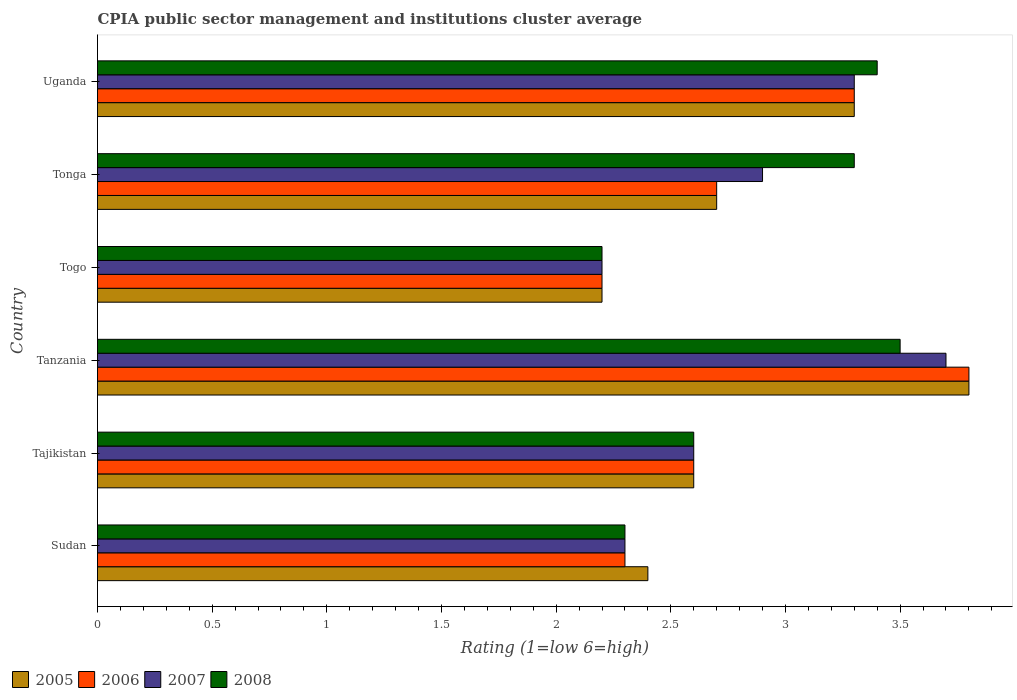How many different coloured bars are there?
Keep it short and to the point. 4. How many bars are there on the 1st tick from the top?
Provide a short and direct response. 4. How many bars are there on the 4th tick from the bottom?
Offer a terse response. 4. What is the label of the 1st group of bars from the top?
Keep it short and to the point. Uganda. What is the CPIA rating in 2008 in Tanzania?
Your response must be concise. 3.5. Across all countries, what is the maximum CPIA rating in 2006?
Offer a terse response. 3.8. Across all countries, what is the minimum CPIA rating in 2007?
Ensure brevity in your answer.  2.2. In which country was the CPIA rating in 2006 maximum?
Your response must be concise. Tanzania. In which country was the CPIA rating in 2005 minimum?
Your answer should be compact. Togo. What is the total CPIA rating in 2008 in the graph?
Ensure brevity in your answer.  17.3. What is the difference between the CPIA rating in 2008 in Tajikistan and that in Tanzania?
Ensure brevity in your answer.  -0.9. What is the difference between the CPIA rating in 2005 in Togo and the CPIA rating in 2008 in Uganda?
Offer a very short reply. -1.2. What is the average CPIA rating in 2008 per country?
Your answer should be very brief. 2.88. What is the difference between the CPIA rating in 2005 and CPIA rating in 2007 in Tanzania?
Provide a short and direct response. 0.1. In how many countries, is the CPIA rating in 2005 greater than 3.4 ?
Give a very brief answer. 1. What is the ratio of the CPIA rating in 2006 in Sudan to that in Togo?
Keep it short and to the point. 1.05. Is the difference between the CPIA rating in 2005 in Tonga and Uganda greater than the difference between the CPIA rating in 2007 in Tonga and Uganda?
Provide a succinct answer. No. What is the difference between the highest and the lowest CPIA rating in 2008?
Keep it short and to the point. 1.3. Is it the case that in every country, the sum of the CPIA rating in 2005 and CPIA rating in 2007 is greater than the sum of CPIA rating in 2006 and CPIA rating in 2008?
Your response must be concise. No. Are all the bars in the graph horizontal?
Ensure brevity in your answer.  Yes. How many countries are there in the graph?
Offer a terse response. 6. Are the values on the major ticks of X-axis written in scientific E-notation?
Offer a very short reply. No. Does the graph contain any zero values?
Your response must be concise. No. Does the graph contain grids?
Keep it short and to the point. No. Where does the legend appear in the graph?
Provide a short and direct response. Bottom left. How many legend labels are there?
Provide a succinct answer. 4. How are the legend labels stacked?
Provide a short and direct response. Horizontal. What is the title of the graph?
Ensure brevity in your answer.  CPIA public sector management and institutions cluster average. What is the Rating (1=low 6=high) of 2005 in Sudan?
Your answer should be very brief. 2.4. What is the Rating (1=low 6=high) in 2006 in Sudan?
Make the answer very short. 2.3. What is the Rating (1=low 6=high) of 2008 in Tajikistan?
Offer a very short reply. 2.6. What is the Rating (1=low 6=high) of 2007 in Tanzania?
Offer a terse response. 3.7. What is the Rating (1=low 6=high) of 2005 in Togo?
Keep it short and to the point. 2.2. What is the Rating (1=low 6=high) of 2008 in Togo?
Offer a terse response. 2.2. What is the Rating (1=low 6=high) of 2005 in Tonga?
Ensure brevity in your answer.  2.7. What is the Rating (1=low 6=high) in 2007 in Tonga?
Give a very brief answer. 2.9. What is the Rating (1=low 6=high) in 2008 in Tonga?
Keep it short and to the point. 3.3. What is the Rating (1=low 6=high) of 2005 in Uganda?
Your answer should be very brief. 3.3. What is the Rating (1=low 6=high) of 2008 in Uganda?
Offer a terse response. 3.4. Across all countries, what is the maximum Rating (1=low 6=high) in 2006?
Your answer should be very brief. 3.8. Across all countries, what is the maximum Rating (1=low 6=high) of 2007?
Offer a terse response. 3.7. Across all countries, what is the maximum Rating (1=low 6=high) of 2008?
Your answer should be compact. 3.5. What is the total Rating (1=low 6=high) in 2007 in the graph?
Provide a succinct answer. 17. What is the difference between the Rating (1=low 6=high) of 2005 in Sudan and that in Tajikistan?
Offer a terse response. -0.2. What is the difference between the Rating (1=low 6=high) of 2006 in Sudan and that in Tajikistan?
Ensure brevity in your answer.  -0.3. What is the difference between the Rating (1=low 6=high) of 2008 in Sudan and that in Tajikistan?
Offer a terse response. -0.3. What is the difference between the Rating (1=low 6=high) in 2005 in Sudan and that in Tanzania?
Give a very brief answer. -1.4. What is the difference between the Rating (1=low 6=high) in 2006 in Sudan and that in Tanzania?
Your answer should be very brief. -1.5. What is the difference between the Rating (1=low 6=high) in 2006 in Sudan and that in Tonga?
Offer a very short reply. -0.4. What is the difference between the Rating (1=low 6=high) in 2007 in Sudan and that in Tonga?
Keep it short and to the point. -0.6. What is the difference between the Rating (1=low 6=high) of 2008 in Sudan and that in Tonga?
Keep it short and to the point. -1. What is the difference between the Rating (1=low 6=high) in 2006 in Sudan and that in Uganda?
Your answer should be very brief. -1. What is the difference between the Rating (1=low 6=high) in 2008 in Sudan and that in Uganda?
Give a very brief answer. -1.1. What is the difference between the Rating (1=low 6=high) in 2005 in Tajikistan and that in Tanzania?
Keep it short and to the point. -1.2. What is the difference between the Rating (1=low 6=high) of 2006 in Tajikistan and that in Tanzania?
Your answer should be compact. -1.2. What is the difference between the Rating (1=low 6=high) of 2007 in Tajikistan and that in Tanzania?
Your answer should be very brief. -1.1. What is the difference between the Rating (1=low 6=high) in 2006 in Tajikistan and that in Tonga?
Keep it short and to the point. -0.1. What is the difference between the Rating (1=low 6=high) of 2008 in Tajikistan and that in Tonga?
Ensure brevity in your answer.  -0.7. What is the difference between the Rating (1=low 6=high) in 2005 in Tajikistan and that in Uganda?
Your response must be concise. -0.7. What is the difference between the Rating (1=low 6=high) of 2007 in Tajikistan and that in Uganda?
Offer a terse response. -0.7. What is the difference between the Rating (1=low 6=high) of 2005 in Tanzania and that in Togo?
Ensure brevity in your answer.  1.6. What is the difference between the Rating (1=low 6=high) in 2008 in Tanzania and that in Togo?
Make the answer very short. 1.3. What is the difference between the Rating (1=low 6=high) of 2006 in Tanzania and that in Tonga?
Your answer should be compact. 1.1. What is the difference between the Rating (1=low 6=high) of 2007 in Tanzania and that in Tonga?
Ensure brevity in your answer.  0.8. What is the difference between the Rating (1=low 6=high) of 2008 in Tanzania and that in Tonga?
Provide a succinct answer. 0.2. What is the difference between the Rating (1=low 6=high) of 2005 in Tanzania and that in Uganda?
Provide a succinct answer. 0.5. What is the difference between the Rating (1=low 6=high) of 2005 in Togo and that in Tonga?
Keep it short and to the point. -0.5. What is the difference between the Rating (1=low 6=high) of 2006 in Togo and that in Tonga?
Your answer should be very brief. -0.5. What is the difference between the Rating (1=low 6=high) in 2008 in Togo and that in Tonga?
Offer a very short reply. -1.1. What is the difference between the Rating (1=low 6=high) of 2007 in Tonga and that in Uganda?
Give a very brief answer. -0.4. What is the difference between the Rating (1=low 6=high) in 2006 in Sudan and the Rating (1=low 6=high) in 2008 in Tajikistan?
Provide a short and direct response. -0.3. What is the difference between the Rating (1=low 6=high) in 2005 in Sudan and the Rating (1=low 6=high) in 2007 in Tanzania?
Offer a terse response. -1.3. What is the difference between the Rating (1=low 6=high) in 2005 in Sudan and the Rating (1=low 6=high) in 2008 in Tanzania?
Provide a short and direct response. -1.1. What is the difference between the Rating (1=low 6=high) of 2006 in Sudan and the Rating (1=low 6=high) of 2007 in Tanzania?
Ensure brevity in your answer.  -1.4. What is the difference between the Rating (1=low 6=high) of 2006 in Sudan and the Rating (1=low 6=high) of 2008 in Tanzania?
Keep it short and to the point. -1.2. What is the difference between the Rating (1=low 6=high) in 2007 in Sudan and the Rating (1=low 6=high) in 2008 in Tanzania?
Offer a terse response. -1.2. What is the difference between the Rating (1=low 6=high) of 2005 in Sudan and the Rating (1=low 6=high) of 2006 in Togo?
Give a very brief answer. 0.2. What is the difference between the Rating (1=low 6=high) in 2005 in Sudan and the Rating (1=low 6=high) in 2007 in Togo?
Your answer should be very brief. 0.2. What is the difference between the Rating (1=low 6=high) in 2007 in Sudan and the Rating (1=low 6=high) in 2008 in Togo?
Provide a succinct answer. 0.1. What is the difference between the Rating (1=low 6=high) in 2005 in Sudan and the Rating (1=low 6=high) in 2008 in Tonga?
Provide a succinct answer. -0.9. What is the difference between the Rating (1=low 6=high) of 2006 in Sudan and the Rating (1=low 6=high) of 2008 in Tonga?
Your response must be concise. -1. What is the difference between the Rating (1=low 6=high) of 2007 in Sudan and the Rating (1=low 6=high) of 2008 in Tonga?
Ensure brevity in your answer.  -1. What is the difference between the Rating (1=low 6=high) in 2005 in Sudan and the Rating (1=low 6=high) in 2006 in Uganda?
Ensure brevity in your answer.  -0.9. What is the difference between the Rating (1=low 6=high) in 2005 in Sudan and the Rating (1=low 6=high) in 2008 in Uganda?
Ensure brevity in your answer.  -1. What is the difference between the Rating (1=low 6=high) of 2006 in Sudan and the Rating (1=low 6=high) of 2007 in Uganda?
Offer a very short reply. -1. What is the difference between the Rating (1=low 6=high) of 2006 in Sudan and the Rating (1=low 6=high) of 2008 in Uganda?
Offer a very short reply. -1.1. What is the difference between the Rating (1=low 6=high) in 2007 in Sudan and the Rating (1=low 6=high) in 2008 in Uganda?
Provide a short and direct response. -1.1. What is the difference between the Rating (1=low 6=high) of 2005 in Tajikistan and the Rating (1=low 6=high) of 2006 in Tanzania?
Your response must be concise. -1.2. What is the difference between the Rating (1=low 6=high) of 2005 in Tajikistan and the Rating (1=low 6=high) of 2008 in Tanzania?
Keep it short and to the point. -0.9. What is the difference between the Rating (1=low 6=high) of 2007 in Tajikistan and the Rating (1=low 6=high) of 2008 in Tanzania?
Make the answer very short. -0.9. What is the difference between the Rating (1=low 6=high) in 2005 in Tajikistan and the Rating (1=low 6=high) in 2006 in Togo?
Keep it short and to the point. 0.4. What is the difference between the Rating (1=low 6=high) of 2006 in Tajikistan and the Rating (1=low 6=high) of 2007 in Togo?
Your response must be concise. 0.4. What is the difference between the Rating (1=low 6=high) in 2005 in Tajikistan and the Rating (1=low 6=high) in 2007 in Tonga?
Your answer should be very brief. -0.3. What is the difference between the Rating (1=low 6=high) in 2005 in Tajikistan and the Rating (1=low 6=high) in 2008 in Tonga?
Ensure brevity in your answer.  -0.7. What is the difference between the Rating (1=low 6=high) of 2006 in Tajikistan and the Rating (1=low 6=high) of 2007 in Tonga?
Offer a terse response. -0.3. What is the difference between the Rating (1=low 6=high) in 2007 in Tajikistan and the Rating (1=low 6=high) in 2008 in Tonga?
Provide a succinct answer. -0.7. What is the difference between the Rating (1=low 6=high) in 2005 in Tajikistan and the Rating (1=low 6=high) in 2006 in Uganda?
Your response must be concise. -0.7. What is the difference between the Rating (1=low 6=high) of 2005 in Tajikistan and the Rating (1=low 6=high) of 2007 in Uganda?
Your response must be concise. -0.7. What is the difference between the Rating (1=low 6=high) of 2005 in Tajikistan and the Rating (1=low 6=high) of 2008 in Uganda?
Provide a short and direct response. -0.8. What is the difference between the Rating (1=low 6=high) of 2006 in Tajikistan and the Rating (1=low 6=high) of 2007 in Uganda?
Ensure brevity in your answer.  -0.7. What is the difference between the Rating (1=low 6=high) of 2006 in Tajikistan and the Rating (1=low 6=high) of 2008 in Uganda?
Make the answer very short. -0.8. What is the difference between the Rating (1=low 6=high) in 2005 in Tanzania and the Rating (1=low 6=high) in 2006 in Togo?
Your answer should be compact. 1.6. What is the difference between the Rating (1=low 6=high) of 2005 in Tanzania and the Rating (1=low 6=high) of 2007 in Togo?
Keep it short and to the point. 1.6. What is the difference between the Rating (1=low 6=high) in 2006 in Tanzania and the Rating (1=low 6=high) in 2007 in Togo?
Give a very brief answer. 1.6. What is the difference between the Rating (1=low 6=high) in 2005 in Tanzania and the Rating (1=low 6=high) in 2006 in Tonga?
Your answer should be compact. 1.1. What is the difference between the Rating (1=low 6=high) in 2005 in Tanzania and the Rating (1=low 6=high) in 2006 in Uganda?
Your answer should be very brief. 0.5. What is the difference between the Rating (1=low 6=high) in 2005 in Tanzania and the Rating (1=low 6=high) in 2007 in Uganda?
Your answer should be very brief. 0.5. What is the difference between the Rating (1=low 6=high) of 2006 in Tanzania and the Rating (1=low 6=high) of 2008 in Uganda?
Give a very brief answer. 0.4. What is the difference between the Rating (1=low 6=high) in 2005 in Togo and the Rating (1=low 6=high) in 2007 in Tonga?
Offer a terse response. -0.7. What is the difference between the Rating (1=low 6=high) of 2006 in Togo and the Rating (1=low 6=high) of 2008 in Tonga?
Your response must be concise. -1.1. What is the difference between the Rating (1=low 6=high) of 2005 in Togo and the Rating (1=low 6=high) of 2006 in Uganda?
Your answer should be compact. -1.1. What is the difference between the Rating (1=low 6=high) in 2005 in Togo and the Rating (1=low 6=high) in 2007 in Uganda?
Give a very brief answer. -1.1. What is the difference between the Rating (1=low 6=high) in 2006 in Togo and the Rating (1=low 6=high) in 2008 in Uganda?
Your answer should be compact. -1.2. What is the difference between the Rating (1=low 6=high) in 2007 in Togo and the Rating (1=low 6=high) in 2008 in Uganda?
Provide a succinct answer. -1.2. What is the difference between the Rating (1=low 6=high) in 2005 in Tonga and the Rating (1=low 6=high) in 2008 in Uganda?
Keep it short and to the point. -0.7. What is the difference between the Rating (1=low 6=high) of 2006 in Tonga and the Rating (1=low 6=high) of 2007 in Uganda?
Keep it short and to the point. -0.6. What is the average Rating (1=low 6=high) of 2005 per country?
Your answer should be compact. 2.83. What is the average Rating (1=low 6=high) of 2006 per country?
Give a very brief answer. 2.82. What is the average Rating (1=low 6=high) in 2007 per country?
Offer a terse response. 2.83. What is the average Rating (1=low 6=high) of 2008 per country?
Make the answer very short. 2.88. What is the difference between the Rating (1=low 6=high) in 2005 and Rating (1=low 6=high) in 2006 in Tajikistan?
Your response must be concise. 0. What is the difference between the Rating (1=low 6=high) of 2006 and Rating (1=low 6=high) of 2007 in Tajikistan?
Ensure brevity in your answer.  0. What is the difference between the Rating (1=low 6=high) of 2006 and Rating (1=low 6=high) of 2008 in Tajikistan?
Keep it short and to the point. 0. What is the difference between the Rating (1=low 6=high) in 2007 and Rating (1=low 6=high) in 2008 in Tajikistan?
Ensure brevity in your answer.  0. What is the difference between the Rating (1=low 6=high) in 2005 and Rating (1=low 6=high) in 2007 in Tanzania?
Offer a terse response. 0.1. What is the difference between the Rating (1=low 6=high) in 2005 and Rating (1=low 6=high) in 2006 in Togo?
Make the answer very short. 0. What is the difference between the Rating (1=low 6=high) of 2005 and Rating (1=low 6=high) of 2008 in Togo?
Offer a very short reply. 0. What is the difference between the Rating (1=low 6=high) in 2006 and Rating (1=low 6=high) in 2008 in Togo?
Keep it short and to the point. 0. What is the difference between the Rating (1=low 6=high) of 2005 and Rating (1=low 6=high) of 2007 in Tonga?
Ensure brevity in your answer.  -0.2. What is the difference between the Rating (1=low 6=high) of 2007 and Rating (1=low 6=high) of 2008 in Tonga?
Give a very brief answer. -0.4. What is the difference between the Rating (1=low 6=high) in 2005 and Rating (1=low 6=high) in 2006 in Uganda?
Ensure brevity in your answer.  0. What is the difference between the Rating (1=low 6=high) of 2006 and Rating (1=low 6=high) of 2007 in Uganda?
Your answer should be compact. 0. What is the difference between the Rating (1=low 6=high) of 2006 and Rating (1=low 6=high) of 2008 in Uganda?
Ensure brevity in your answer.  -0.1. What is the ratio of the Rating (1=low 6=high) in 2006 in Sudan to that in Tajikistan?
Offer a very short reply. 0.88. What is the ratio of the Rating (1=low 6=high) in 2007 in Sudan to that in Tajikistan?
Offer a terse response. 0.88. What is the ratio of the Rating (1=low 6=high) in 2008 in Sudan to that in Tajikistan?
Give a very brief answer. 0.88. What is the ratio of the Rating (1=low 6=high) in 2005 in Sudan to that in Tanzania?
Provide a succinct answer. 0.63. What is the ratio of the Rating (1=low 6=high) of 2006 in Sudan to that in Tanzania?
Your answer should be very brief. 0.61. What is the ratio of the Rating (1=low 6=high) of 2007 in Sudan to that in Tanzania?
Provide a short and direct response. 0.62. What is the ratio of the Rating (1=low 6=high) of 2008 in Sudan to that in Tanzania?
Make the answer very short. 0.66. What is the ratio of the Rating (1=low 6=high) in 2005 in Sudan to that in Togo?
Give a very brief answer. 1.09. What is the ratio of the Rating (1=low 6=high) of 2006 in Sudan to that in Togo?
Make the answer very short. 1.05. What is the ratio of the Rating (1=low 6=high) of 2007 in Sudan to that in Togo?
Ensure brevity in your answer.  1.05. What is the ratio of the Rating (1=low 6=high) of 2008 in Sudan to that in Togo?
Give a very brief answer. 1.05. What is the ratio of the Rating (1=low 6=high) in 2005 in Sudan to that in Tonga?
Provide a succinct answer. 0.89. What is the ratio of the Rating (1=low 6=high) of 2006 in Sudan to that in Tonga?
Provide a short and direct response. 0.85. What is the ratio of the Rating (1=low 6=high) in 2007 in Sudan to that in Tonga?
Offer a very short reply. 0.79. What is the ratio of the Rating (1=low 6=high) of 2008 in Sudan to that in Tonga?
Provide a short and direct response. 0.7. What is the ratio of the Rating (1=low 6=high) in 2005 in Sudan to that in Uganda?
Your answer should be very brief. 0.73. What is the ratio of the Rating (1=low 6=high) of 2006 in Sudan to that in Uganda?
Provide a short and direct response. 0.7. What is the ratio of the Rating (1=low 6=high) of 2007 in Sudan to that in Uganda?
Offer a terse response. 0.7. What is the ratio of the Rating (1=low 6=high) in 2008 in Sudan to that in Uganda?
Give a very brief answer. 0.68. What is the ratio of the Rating (1=low 6=high) in 2005 in Tajikistan to that in Tanzania?
Ensure brevity in your answer.  0.68. What is the ratio of the Rating (1=low 6=high) of 2006 in Tajikistan to that in Tanzania?
Your response must be concise. 0.68. What is the ratio of the Rating (1=low 6=high) of 2007 in Tajikistan to that in Tanzania?
Your answer should be compact. 0.7. What is the ratio of the Rating (1=low 6=high) of 2008 in Tajikistan to that in Tanzania?
Make the answer very short. 0.74. What is the ratio of the Rating (1=low 6=high) of 2005 in Tajikistan to that in Togo?
Your answer should be compact. 1.18. What is the ratio of the Rating (1=low 6=high) of 2006 in Tajikistan to that in Togo?
Keep it short and to the point. 1.18. What is the ratio of the Rating (1=low 6=high) in 2007 in Tajikistan to that in Togo?
Keep it short and to the point. 1.18. What is the ratio of the Rating (1=low 6=high) of 2008 in Tajikistan to that in Togo?
Give a very brief answer. 1.18. What is the ratio of the Rating (1=low 6=high) of 2005 in Tajikistan to that in Tonga?
Keep it short and to the point. 0.96. What is the ratio of the Rating (1=low 6=high) of 2007 in Tajikistan to that in Tonga?
Your answer should be very brief. 0.9. What is the ratio of the Rating (1=low 6=high) in 2008 in Tajikistan to that in Tonga?
Your answer should be compact. 0.79. What is the ratio of the Rating (1=low 6=high) of 2005 in Tajikistan to that in Uganda?
Provide a short and direct response. 0.79. What is the ratio of the Rating (1=low 6=high) in 2006 in Tajikistan to that in Uganda?
Keep it short and to the point. 0.79. What is the ratio of the Rating (1=low 6=high) in 2007 in Tajikistan to that in Uganda?
Offer a terse response. 0.79. What is the ratio of the Rating (1=low 6=high) in 2008 in Tajikistan to that in Uganda?
Offer a very short reply. 0.76. What is the ratio of the Rating (1=low 6=high) of 2005 in Tanzania to that in Togo?
Your answer should be very brief. 1.73. What is the ratio of the Rating (1=low 6=high) in 2006 in Tanzania to that in Togo?
Keep it short and to the point. 1.73. What is the ratio of the Rating (1=low 6=high) of 2007 in Tanzania to that in Togo?
Make the answer very short. 1.68. What is the ratio of the Rating (1=low 6=high) of 2008 in Tanzania to that in Togo?
Your answer should be very brief. 1.59. What is the ratio of the Rating (1=low 6=high) in 2005 in Tanzania to that in Tonga?
Provide a short and direct response. 1.41. What is the ratio of the Rating (1=low 6=high) in 2006 in Tanzania to that in Tonga?
Your response must be concise. 1.41. What is the ratio of the Rating (1=low 6=high) of 2007 in Tanzania to that in Tonga?
Make the answer very short. 1.28. What is the ratio of the Rating (1=low 6=high) in 2008 in Tanzania to that in Tonga?
Offer a terse response. 1.06. What is the ratio of the Rating (1=low 6=high) in 2005 in Tanzania to that in Uganda?
Your response must be concise. 1.15. What is the ratio of the Rating (1=low 6=high) in 2006 in Tanzania to that in Uganda?
Give a very brief answer. 1.15. What is the ratio of the Rating (1=low 6=high) of 2007 in Tanzania to that in Uganda?
Make the answer very short. 1.12. What is the ratio of the Rating (1=low 6=high) in 2008 in Tanzania to that in Uganda?
Make the answer very short. 1.03. What is the ratio of the Rating (1=low 6=high) in 2005 in Togo to that in Tonga?
Keep it short and to the point. 0.81. What is the ratio of the Rating (1=low 6=high) in 2006 in Togo to that in Tonga?
Offer a terse response. 0.81. What is the ratio of the Rating (1=low 6=high) in 2007 in Togo to that in Tonga?
Provide a short and direct response. 0.76. What is the ratio of the Rating (1=low 6=high) of 2008 in Togo to that in Tonga?
Make the answer very short. 0.67. What is the ratio of the Rating (1=low 6=high) in 2005 in Togo to that in Uganda?
Provide a short and direct response. 0.67. What is the ratio of the Rating (1=low 6=high) of 2006 in Togo to that in Uganda?
Ensure brevity in your answer.  0.67. What is the ratio of the Rating (1=low 6=high) in 2007 in Togo to that in Uganda?
Your answer should be very brief. 0.67. What is the ratio of the Rating (1=low 6=high) of 2008 in Togo to that in Uganda?
Keep it short and to the point. 0.65. What is the ratio of the Rating (1=low 6=high) of 2005 in Tonga to that in Uganda?
Provide a short and direct response. 0.82. What is the ratio of the Rating (1=low 6=high) in 2006 in Tonga to that in Uganda?
Your response must be concise. 0.82. What is the ratio of the Rating (1=low 6=high) in 2007 in Tonga to that in Uganda?
Your response must be concise. 0.88. What is the ratio of the Rating (1=low 6=high) in 2008 in Tonga to that in Uganda?
Provide a succinct answer. 0.97. What is the difference between the highest and the second highest Rating (1=low 6=high) of 2005?
Offer a terse response. 0.5. What is the difference between the highest and the lowest Rating (1=low 6=high) in 2006?
Make the answer very short. 1.6. 